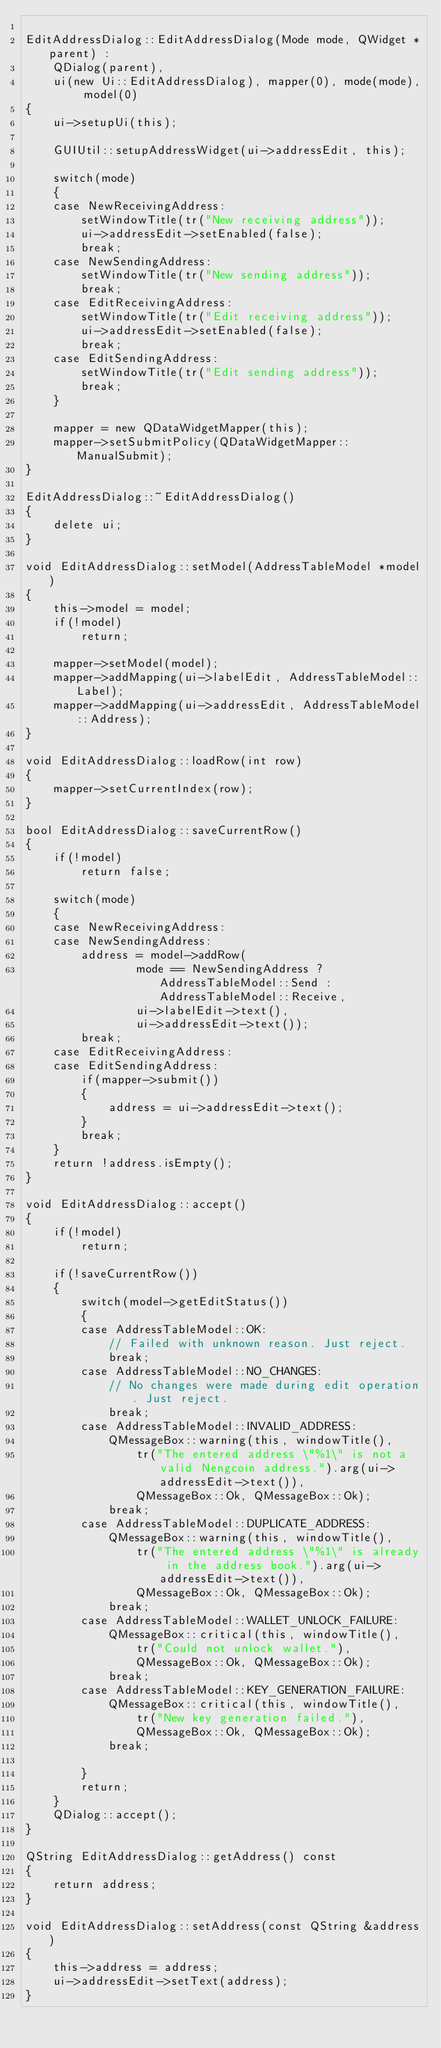Convert code to text. <code><loc_0><loc_0><loc_500><loc_500><_C++_>
EditAddressDialog::EditAddressDialog(Mode mode, QWidget *parent) :
    QDialog(parent),
    ui(new Ui::EditAddressDialog), mapper(0), mode(mode), model(0)
{
    ui->setupUi(this);

    GUIUtil::setupAddressWidget(ui->addressEdit, this);

    switch(mode)
    {
    case NewReceivingAddress:
        setWindowTitle(tr("New receiving address"));
        ui->addressEdit->setEnabled(false);
        break;
    case NewSendingAddress:
        setWindowTitle(tr("New sending address"));
        break;
    case EditReceivingAddress:
        setWindowTitle(tr("Edit receiving address"));
        ui->addressEdit->setEnabled(false);
        break;
    case EditSendingAddress:
        setWindowTitle(tr("Edit sending address"));
        break;
    }

    mapper = new QDataWidgetMapper(this);
    mapper->setSubmitPolicy(QDataWidgetMapper::ManualSubmit);
}

EditAddressDialog::~EditAddressDialog()
{
    delete ui;
}

void EditAddressDialog::setModel(AddressTableModel *model)
{
    this->model = model;
    if(!model)
        return;

    mapper->setModel(model);
    mapper->addMapping(ui->labelEdit, AddressTableModel::Label);
    mapper->addMapping(ui->addressEdit, AddressTableModel::Address);
}

void EditAddressDialog::loadRow(int row)
{
    mapper->setCurrentIndex(row);
}

bool EditAddressDialog::saveCurrentRow()
{
    if(!model)
        return false;

    switch(mode)
    {
    case NewReceivingAddress:
    case NewSendingAddress:
        address = model->addRow(
                mode == NewSendingAddress ? AddressTableModel::Send : AddressTableModel::Receive,
                ui->labelEdit->text(),
                ui->addressEdit->text());
        break;
    case EditReceivingAddress:
    case EditSendingAddress:
        if(mapper->submit())
        {
            address = ui->addressEdit->text();
        }
        break;
    }
    return !address.isEmpty();
}

void EditAddressDialog::accept()
{
    if(!model)
        return;

    if(!saveCurrentRow())
    {
        switch(model->getEditStatus())
        {
        case AddressTableModel::OK:
            // Failed with unknown reason. Just reject.
            break;
        case AddressTableModel::NO_CHANGES:
            // No changes were made during edit operation. Just reject.
            break;
        case AddressTableModel::INVALID_ADDRESS:
            QMessageBox::warning(this, windowTitle(),
                tr("The entered address \"%1\" is not a valid Nengcoin address.").arg(ui->addressEdit->text()),
                QMessageBox::Ok, QMessageBox::Ok);
            break;
        case AddressTableModel::DUPLICATE_ADDRESS:
            QMessageBox::warning(this, windowTitle(),
                tr("The entered address \"%1\" is already in the address book.").arg(ui->addressEdit->text()),
                QMessageBox::Ok, QMessageBox::Ok);
            break;
        case AddressTableModel::WALLET_UNLOCK_FAILURE:
            QMessageBox::critical(this, windowTitle(),
                tr("Could not unlock wallet."),
                QMessageBox::Ok, QMessageBox::Ok);
            break;
        case AddressTableModel::KEY_GENERATION_FAILURE:
            QMessageBox::critical(this, windowTitle(),
                tr("New key generation failed."),
                QMessageBox::Ok, QMessageBox::Ok);
            break;

        }
        return;
    }
    QDialog::accept();
}

QString EditAddressDialog::getAddress() const
{
    return address;
}

void EditAddressDialog::setAddress(const QString &address)
{
    this->address = address;
    ui->addressEdit->setText(address);
}
</code> 